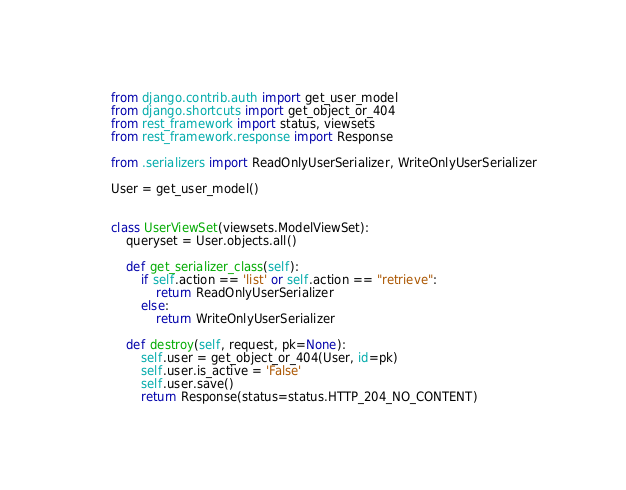Convert code to text. <code><loc_0><loc_0><loc_500><loc_500><_Python_>from django.contrib.auth import get_user_model
from django.shortcuts import get_object_or_404
from rest_framework import status, viewsets
from rest_framework.response import Response

from .serializers import ReadOnlyUserSerializer, WriteOnlyUserSerializer

User = get_user_model()


class UserViewSet(viewsets.ModelViewSet):
    queryset = User.objects.all()

    def get_serializer_class(self):
        if self.action == 'list' or self.action == "retrieve":
            return ReadOnlyUserSerializer
        else:
            return WriteOnlyUserSerializer

    def destroy(self, request, pk=None):
        self.user = get_object_or_404(User, id=pk)
        self.user.is_active = 'False'
        self.user.save()
        return Response(status=status.HTTP_204_NO_CONTENT)
</code> 